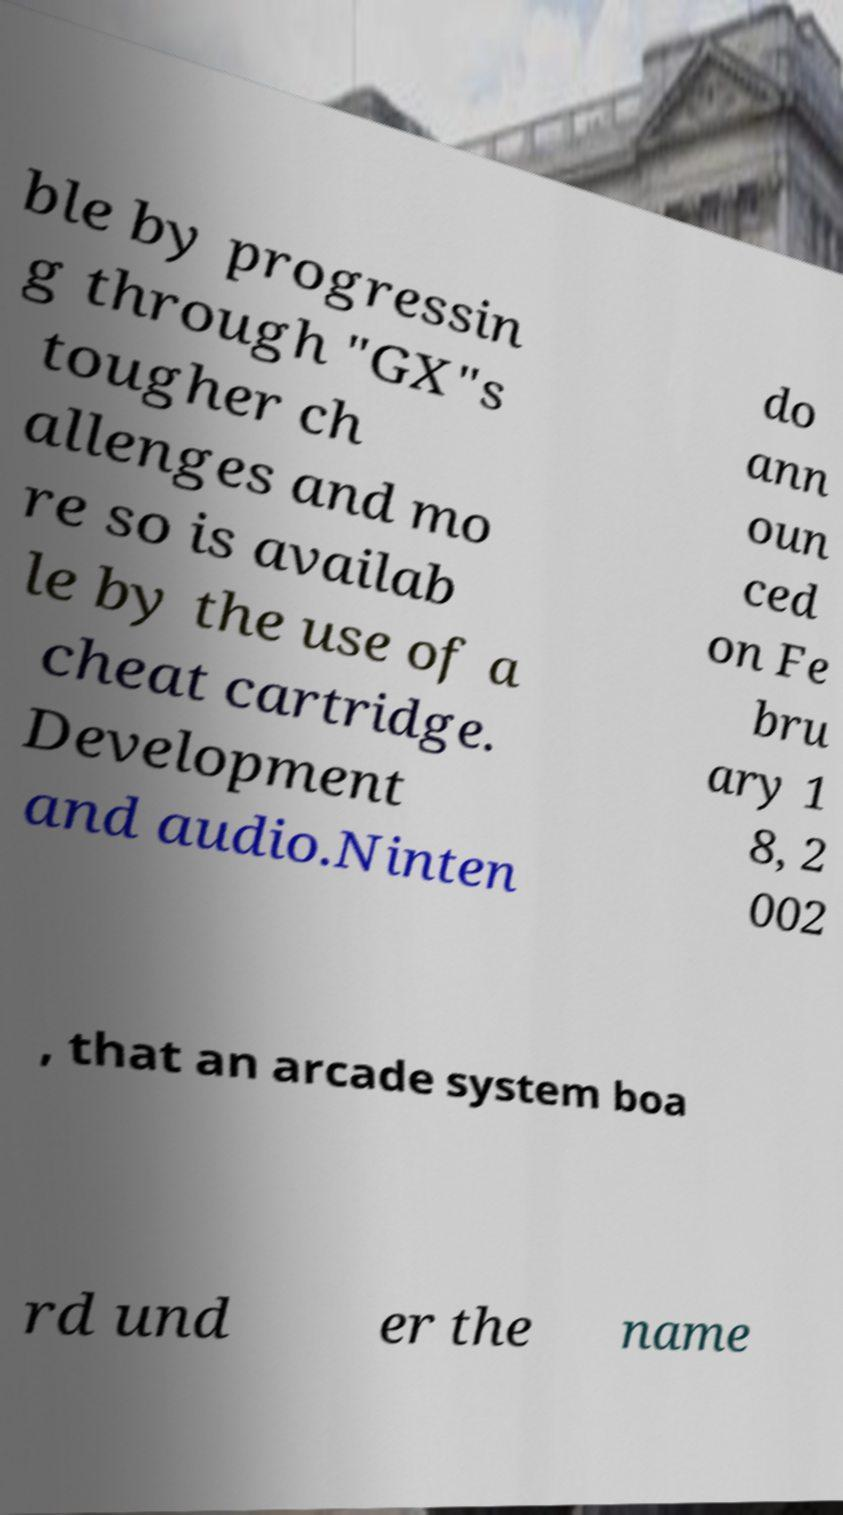Please identify and transcribe the text found in this image. ble by progressin g through "GX"s tougher ch allenges and mo re so is availab le by the use of a cheat cartridge. Development and audio.Ninten do ann oun ced on Fe bru ary 1 8, 2 002 , that an arcade system boa rd und er the name 